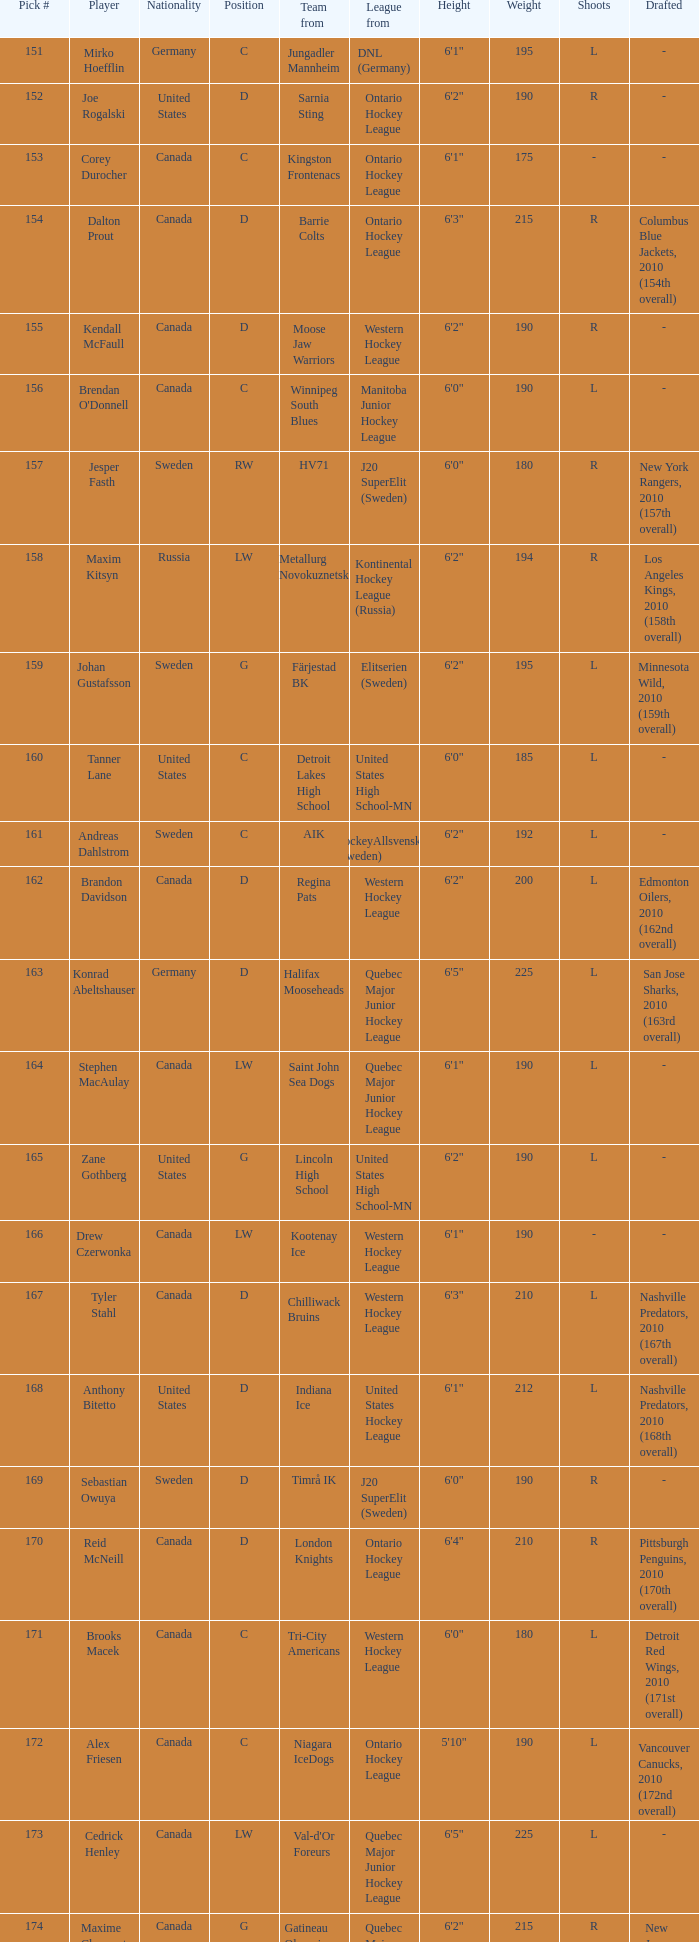What is the position of the team player from Aik? C. 